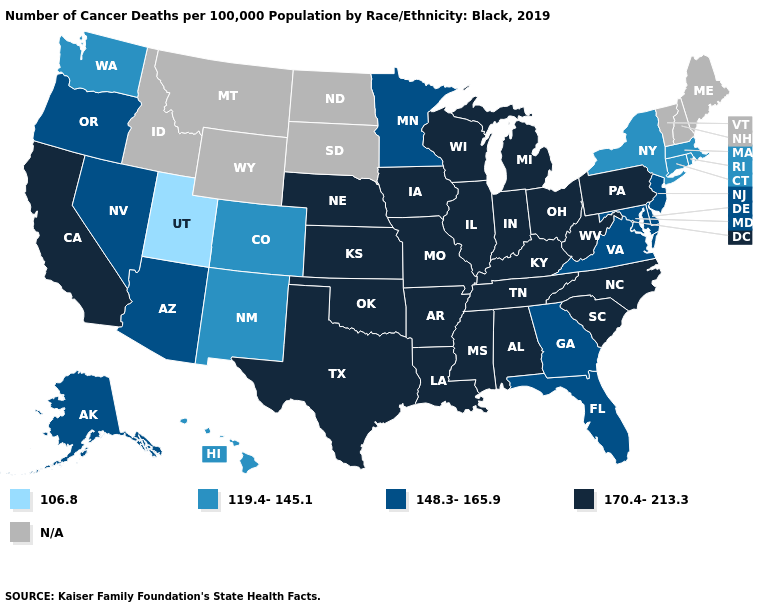Name the states that have a value in the range 106.8?
Be succinct. Utah. Which states have the highest value in the USA?
Write a very short answer. Alabama, Arkansas, California, Illinois, Indiana, Iowa, Kansas, Kentucky, Louisiana, Michigan, Mississippi, Missouri, Nebraska, North Carolina, Ohio, Oklahoma, Pennsylvania, South Carolina, Tennessee, Texas, West Virginia, Wisconsin. Does South Carolina have the highest value in the USA?
Write a very short answer. Yes. Name the states that have a value in the range 148.3-165.9?
Quick response, please. Alaska, Arizona, Delaware, Florida, Georgia, Maryland, Minnesota, Nevada, New Jersey, Oregon, Virginia. Does the first symbol in the legend represent the smallest category?
Write a very short answer. Yes. Name the states that have a value in the range 119.4-145.1?
Keep it brief. Colorado, Connecticut, Hawaii, Massachusetts, New Mexico, New York, Rhode Island, Washington. What is the value of Tennessee?
Give a very brief answer. 170.4-213.3. Which states have the lowest value in the USA?
Quick response, please. Utah. What is the value of New Jersey?
Quick response, please. 148.3-165.9. What is the lowest value in states that border Maryland?
Answer briefly. 148.3-165.9. Does the map have missing data?
Answer briefly. Yes. Does Mississippi have the highest value in the South?
Short answer required. Yes. What is the value of Wisconsin?
Answer briefly. 170.4-213.3. What is the highest value in states that border Colorado?
Keep it brief. 170.4-213.3. 